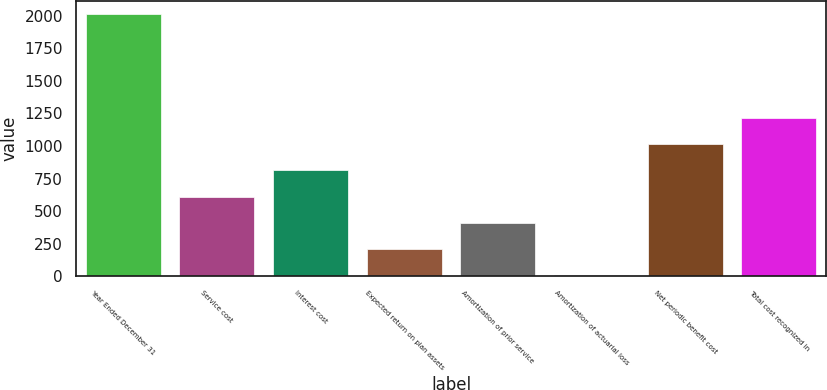<chart> <loc_0><loc_0><loc_500><loc_500><bar_chart><fcel>Year Ended December 31<fcel>Service cost<fcel>Interest cost<fcel>Expected return on plan assets<fcel>Amortization of prior service<fcel>Amortization of actuarial loss<fcel>Net periodic benefit cost<fcel>Total cost recognized in<nl><fcel>2015<fcel>611.5<fcel>812<fcel>210.5<fcel>411<fcel>10<fcel>1012.5<fcel>1213<nl></chart> 